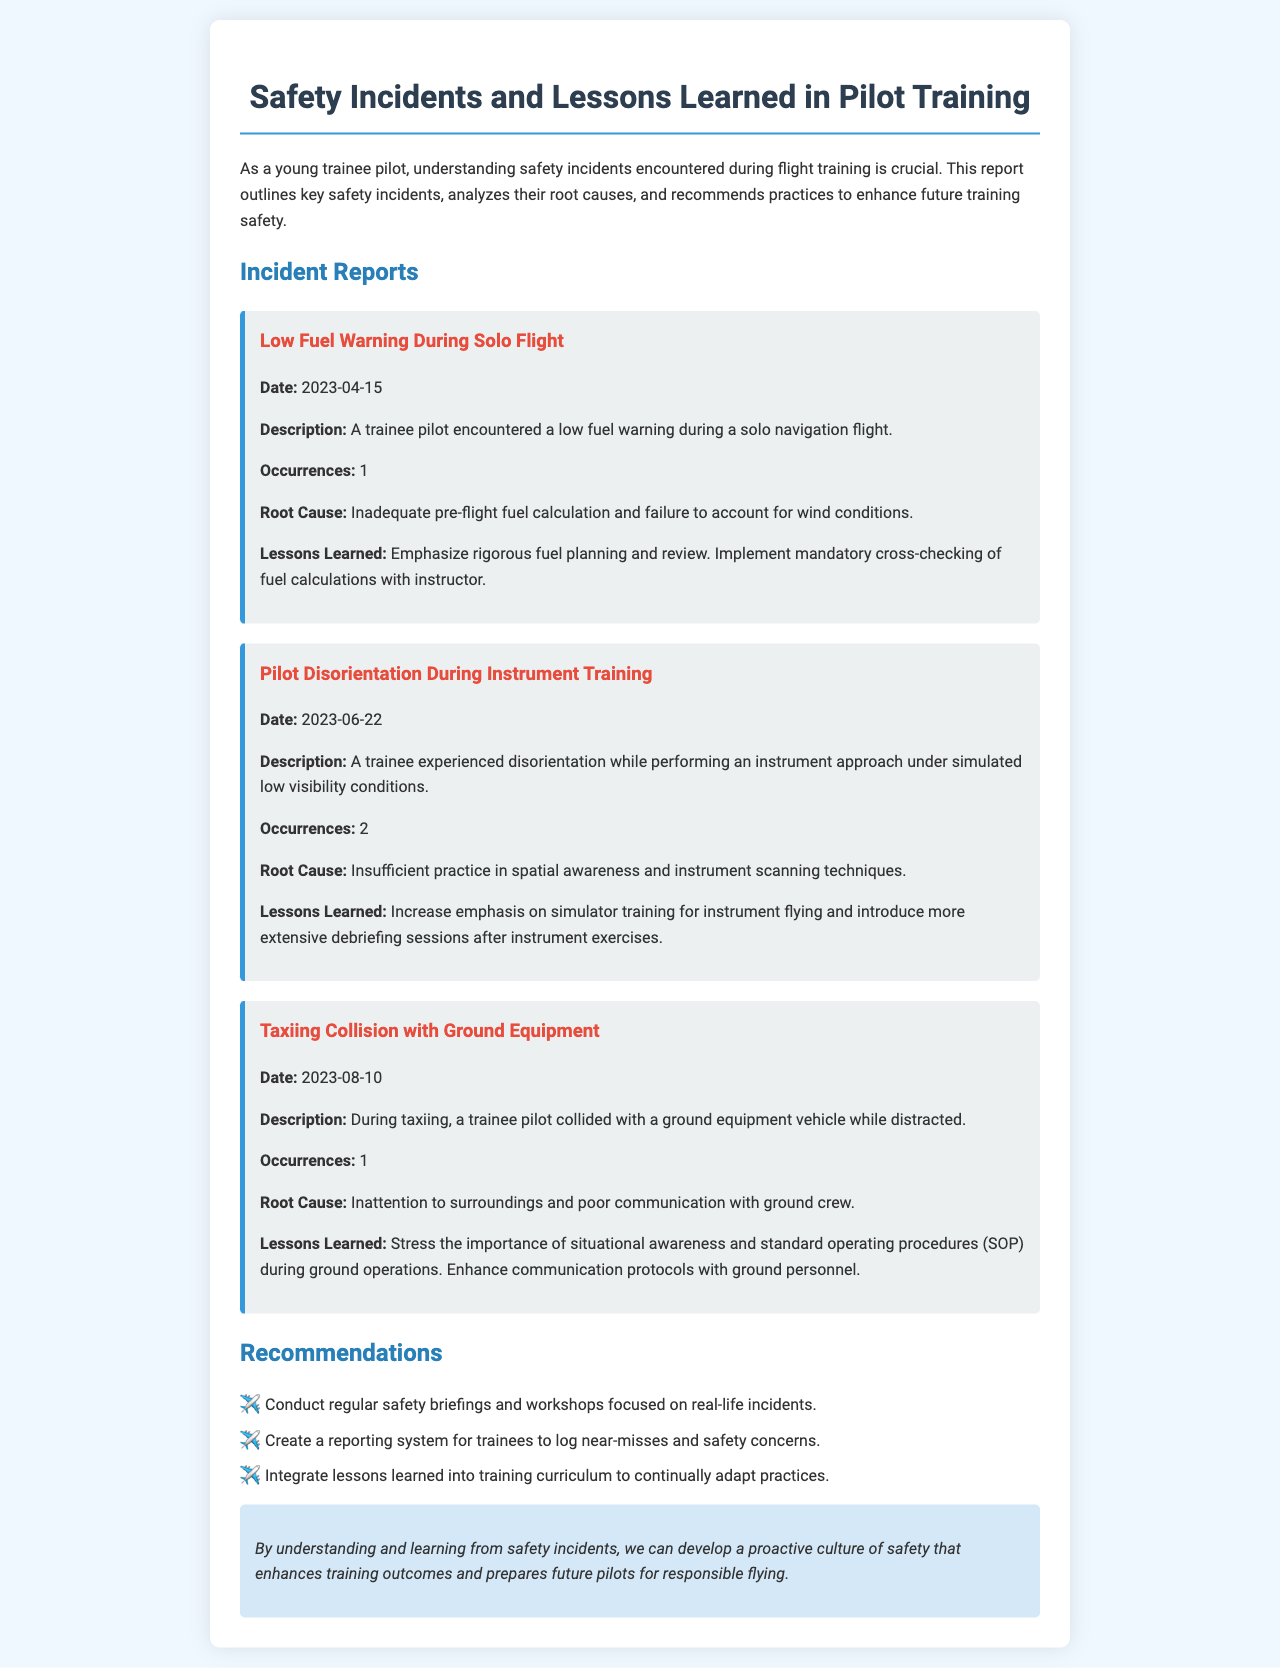what is the title of the report? The title of the report is presented in the heading of the document.
Answer: Safety Incidents and Lessons Learned in Pilot Training how many occurrences were reported for the low fuel warning incident? The occurrences for each incident are detailed in their respective sections.
Answer: 1 on what date did the taxiing collision occur? The specific dates of incidents are provided within each incident report.
Answer: 2023-08-10 what is one of the root causes of the pilot disorientation incident? The root causes are summarized in the incident descriptions across the document.
Answer: Insufficient practice in spatial awareness what lesson was learned from the taxiing collision with ground equipment? Each incident concludes with lessons learned, which are specific actions for improvement.
Answer: Stress the importance of situational awareness how many total recommendations are made in the report? The recommendations are listed at the end of the incident analysis section.
Answer: 3 what type of training should be emphasized for the instrument approach incident? The lessons learned specify the type of training needed for improvement.
Answer: Simulator training what is the recommended practice for future fuel planning? Recommendations for future practices are provided after each incident description.
Answer: Implement mandatory cross-checking of fuel calculations 